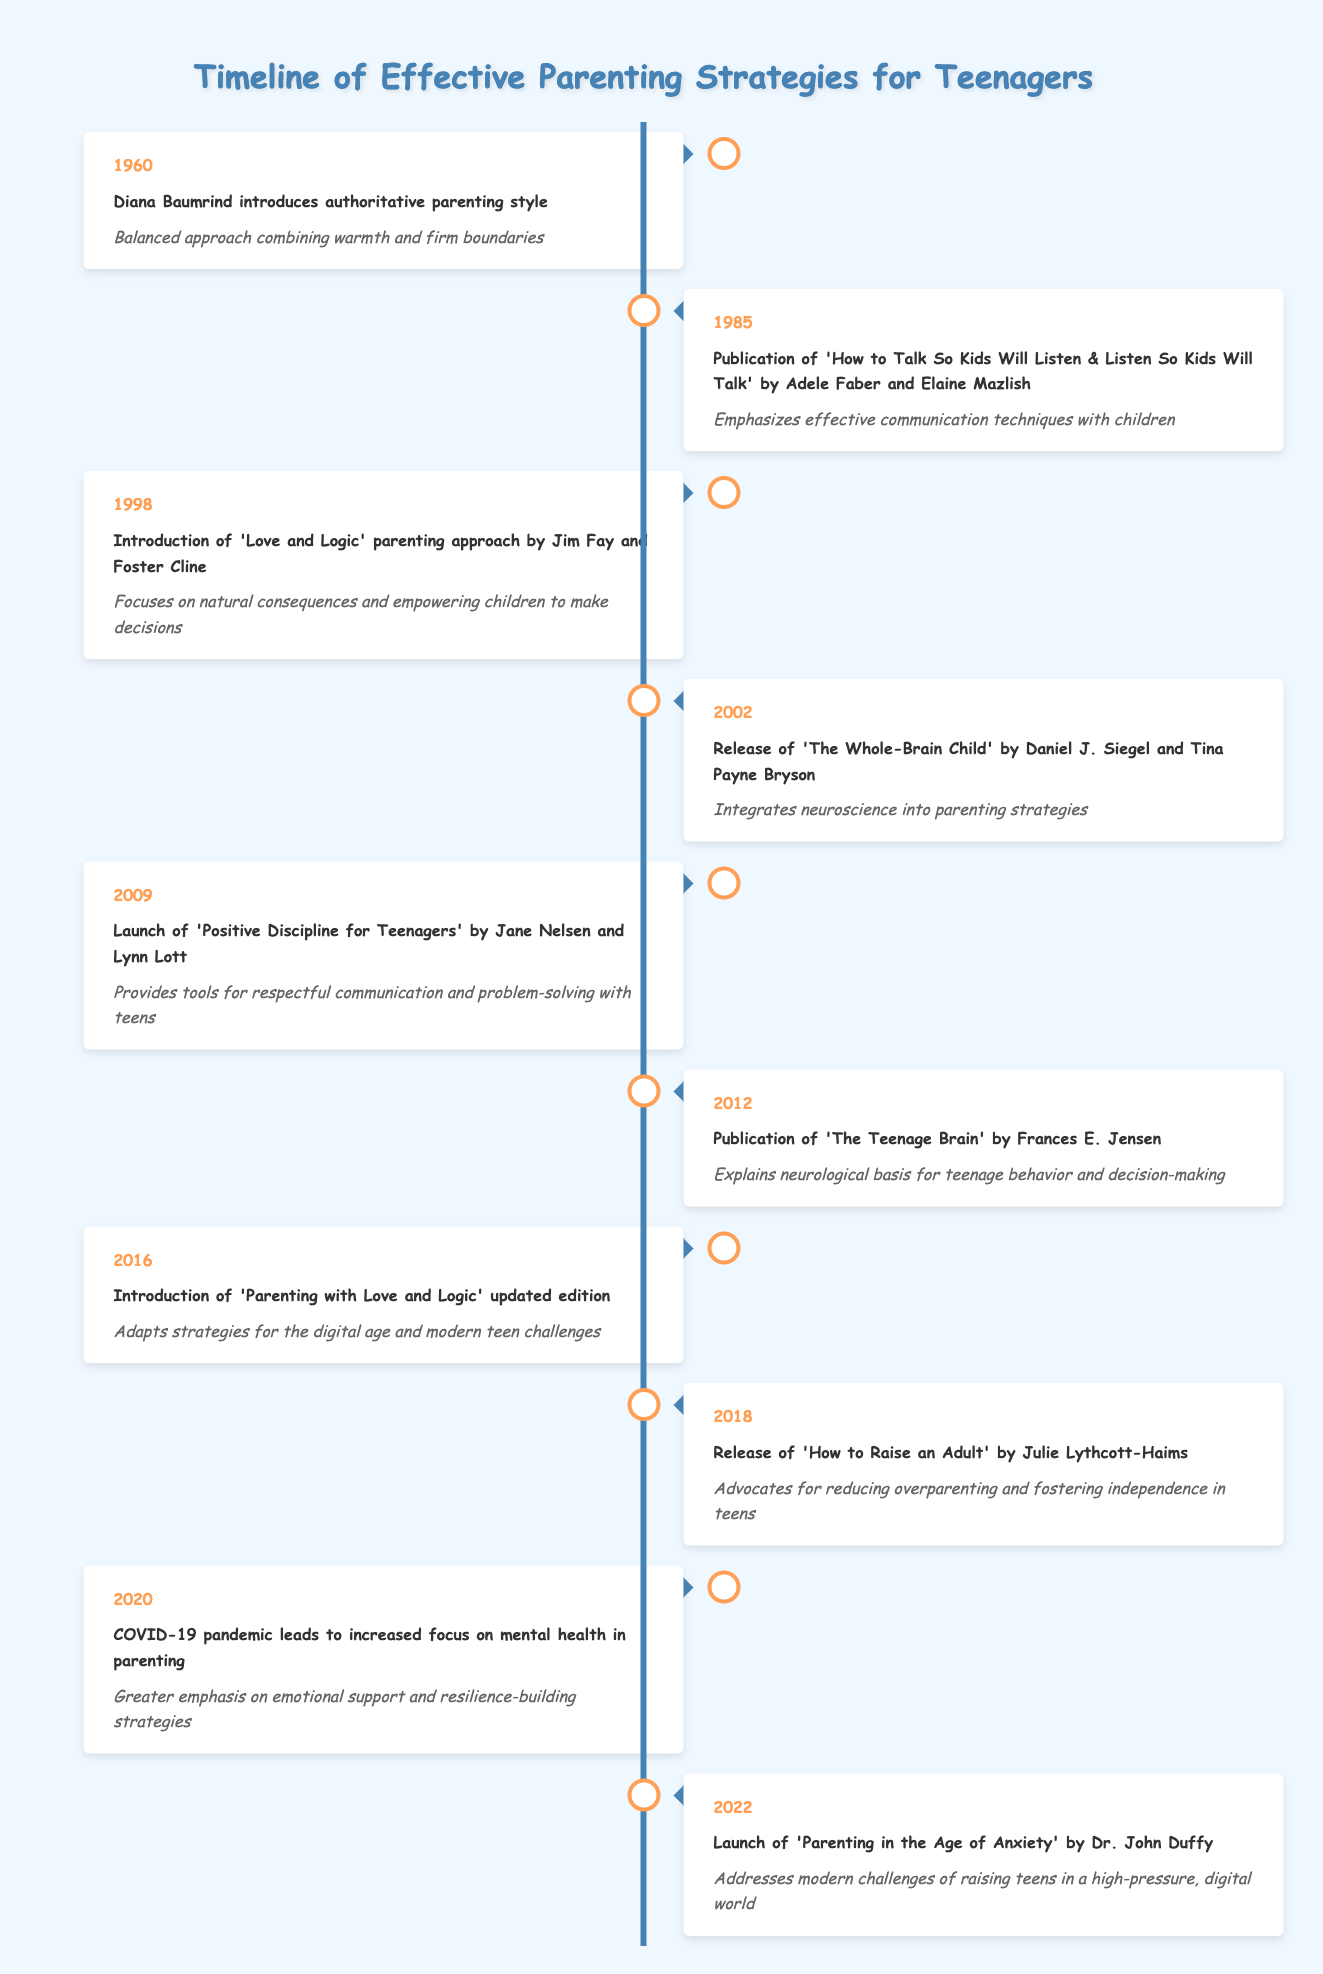What year did Diana Baumrind introduce the authoritative parenting style? The table clearly states that the event "Diana Baumrind introduces authoritative parenting style" occurred in the year 1960.
Answer: 1960 What impact is discussed in relation to the publication of "How to Talk So Kids Will Listen & Listen So Kids Will Talk"? By looking at the entry for the year 1985, the impact of this book is stated as "Emphasizes effective communication techniques with children."
Answer: Emphasizes effective communication techniques with children Was the "Love and Logic" parenting approach introduced before the publication of "The Teenage Brain"? "Love and Logic" was introduced in 1998, while "The Teenage Brain" was published in 2012. Since 1998 is before 2012, the statement is true.
Answer: Yes In which year did the launch of "Positive Discipline for Teenagers" occur, and what is its impact? The entry for the year 2009 indicates that "Positive Discipline for Teenagers" was launched then, and it provides tools for respectful communication and problem-solving with teens.
Answer: 2009; provides tools for respectful communication and problem-solving with teens How many parenting strategies were introduced between 1985 and 2020? Counting the entries from 1985 to 2020, there's one entry in 1985, one in 1998, one in 2002, one in 2009, one in 2012, one in 2016, and one in 2020, leading to a total of 7 strategies introduced in those years.
Answer: 7 What is the combined impact of the events introduced in the years 2002 and 2012? The 2002 event focuses on integrating neuroscience into parenting strategies, while the 2012 event explains the neurological basis for teenage behavior and decision-making. Both emphasize the role of brain understanding in parenting, indicating a trend towards scientifically informed parenting strategies.
Answer: Both emphasize scientific understanding of parenting After the introduction of "Parenting in the Age of Anxiety" in 2022, what modern challenges does it address? The entry for 2022 specifies that "Parenting in the Age of Anxiety" addresses modern challenges faced by raising teens in a high-pressure, digital world, which indicates the focus on contemporary issues.
Answer: Modern challenges of raising teens in a high-pressure, digital world What was the main theme of parenting strategies introduced from 2000 to 2022? The events from 2000 to 2022 predominantly focus on communication, mental health, and addressing modern challenges through scientific understanding and independence fostering, showing an evolution towards more comprehensive approaches to parenting.
Answer: Emphasis on communication, mental health, and modern challenges Is there evidence in the table that suggests a shift towards more independence for teenagers in 2018? The entry from 2018 states that "How to Raise an Adult" advocates for reducing overparenting and fostering independence in teens, indicating a clear shift in philosophy towards promoting independence.
Answer: Yes 